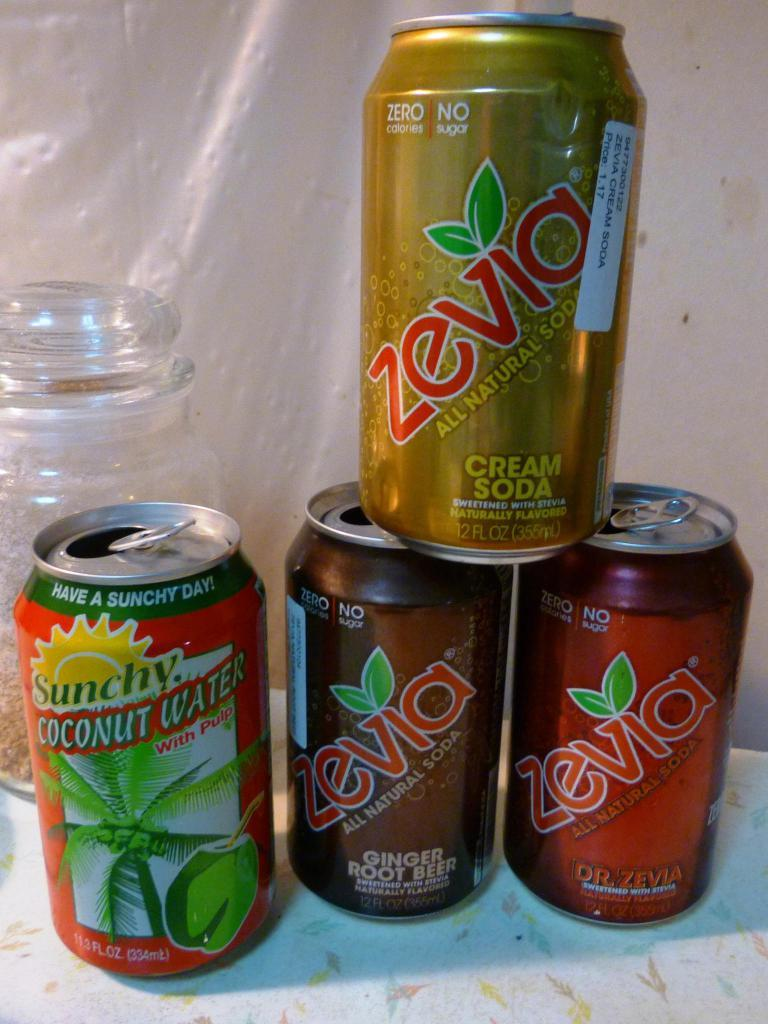<image>
Provide a brief description of the given image. Several cans of Zevia all natural soda with no sugar 